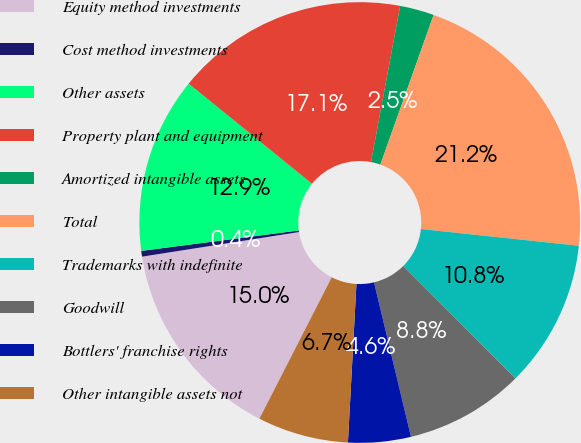Convert chart. <chart><loc_0><loc_0><loc_500><loc_500><pie_chart><fcel>Equity method investments<fcel>Cost method investments<fcel>Other assets<fcel>Property plant and equipment<fcel>Amortized intangible assets<fcel>Total<fcel>Trademarks with indefinite<fcel>Goodwill<fcel>Bottlers' franchise rights<fcel>Other intangible assets not<nl><fcel>15.0%<fcel>0.42%<fcel>12.91%<fcel>17.08%<fcel>2.51%<fcel>21.24%<fcel>10.83%<fcel>8.75%<fcel>4.59%<fcel>6.67%<nl></chart> 